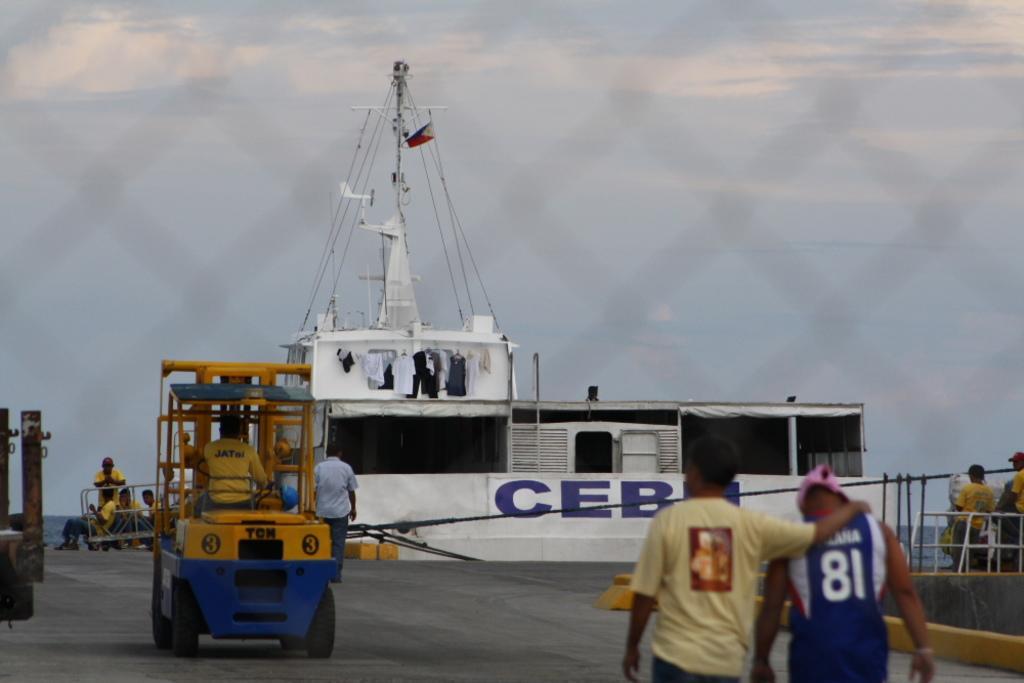Describe this image in one or two sentences. In this image we can see a ship, in front of the ship there few vehicles, which are on the road. On the right side there are two persons walking on the road. In the background there is a sky. 